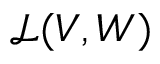Convert formula to latex. <formula><loc_0><loc_0><loc_500><loc_500>\mathcal { L } ( V , W )</formula> 